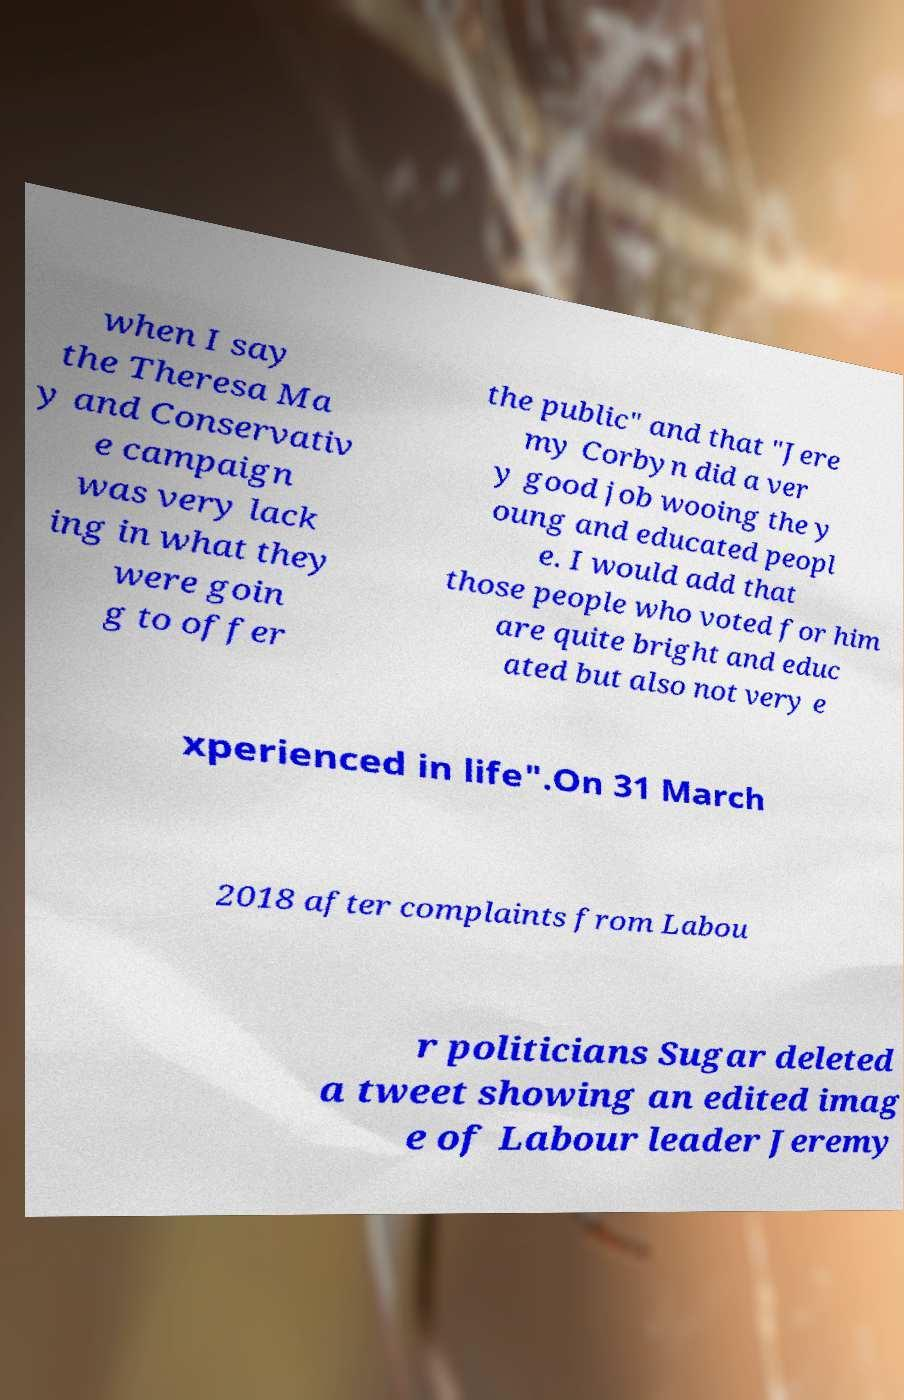Could you assist in decoding the text presented in this image and type it out clearly? when I say the Theresa Ma y and Conservativ e campaign was very lack ing in what they were goin g to offer the public" and that "Jere my Corbyn did a ver y good job wooing the y oung and educated peopl e. I would add that those people who voted for him are quite bright and educ ated but also not very e xperienced in life".On 31 March 2018 after complaints from Labou r politicians Sugar deleted a tweet showing an edited imag e of Labour leader Jeremy 